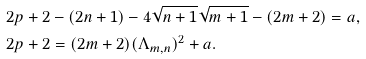<formula> <loc_0><loc_0><loc_500><loc_500>& 2 p + 2 - ( 2 n + 1 ) - 4 \sqrt { n + 1 } \sqrt { m + 1 } - ( 2 m + 2 ) = a , \\ & 2 p + 2 = ( 2 m + 2 ) ( \Lambda _ { m , n } ) ^ { 2 } + a .</formula> 